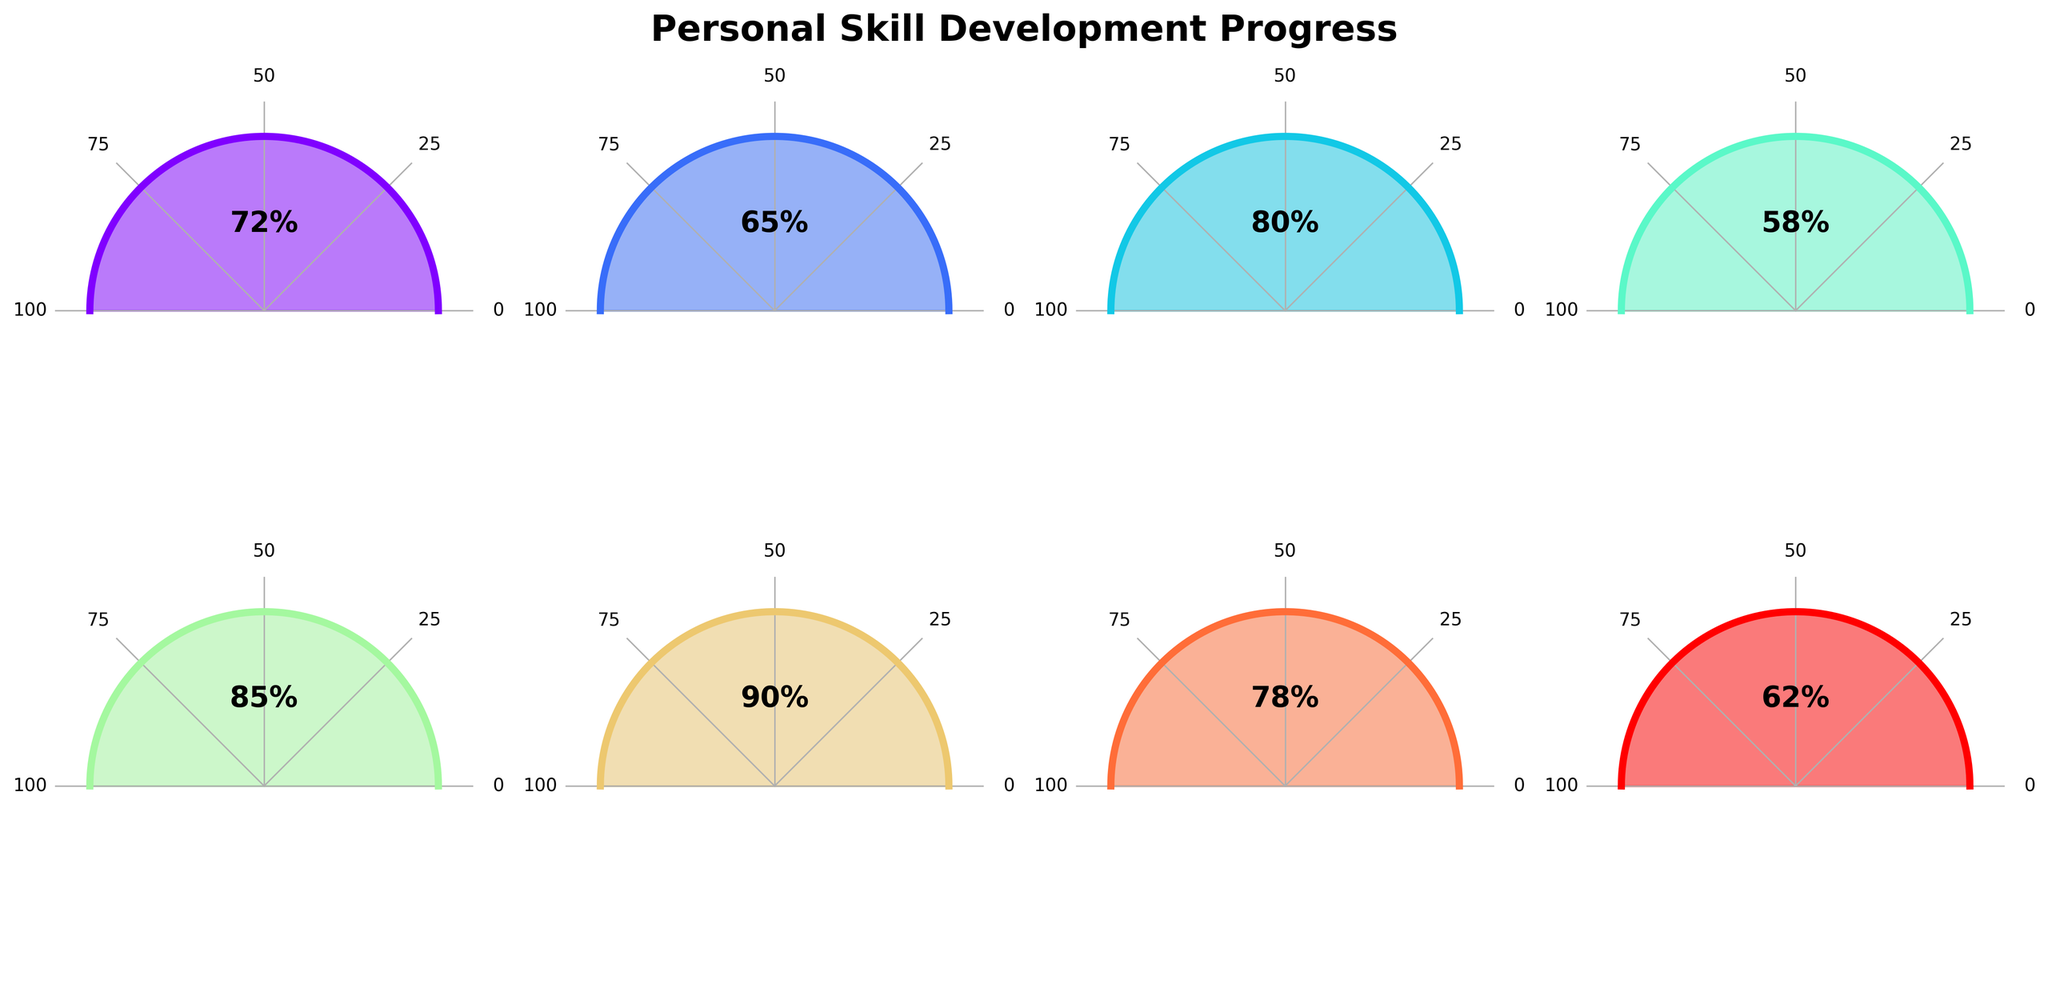What's the title of the figure? The title of the figure is displayed at the top and often serves to provide a brief explanation of what the figure depicts. In this case, the title clearly states, "Personal Skill Development Progress."
Answer: Personal Skill Development Progress How many skills are being tracked in this figure? Each subplot in the figure represents a different skill being tracked. By counting the number of subplots, you can determine how many skills are included. In this figure, there are 2 rows with 4 columns, totaling 8 skills.
Answer: 8 Which skill shows the highest progress percentage? To find the skill with the highest progress percentage, look at the percentage values displayed within each gauge plot. The skill with the highest number is the one with the highest progress. In this case, "Teamwork" has the highest progress at 90%.
Answer: Teamwork What is the mean progress percentage of all skills? To determine the mean progress percentage, sum all the progress percentages and then divide by the number of skills. The percentages are: 72, 65, 80, 58, 85, 90, 78, and 62. Summing these up gives 590. Dividing by the number of skills (8) gives a mean of 73.75%.
Answer: 73.75% Which skills have progress percentages greater than 70%? To find which skills have a progress percentage greater than 70%, scan each subplot for the provided percentage and see which ones are above 70. The skills that satisfy this condition are Communication (72%), Time Management (80%), Problem Solving (85%), Teamwork (90%), and Adaptability (78%).
Answer: Communication, Time Management, Problem Solving, Teamwork, Adaptability Which skill shows the lowest progress percentage? To identify the skill with the lowest progress, look at the percentage in each gauge plot and find the lowest number. Here, "Technical Writing" has the lowest progress at 58%.
Answer: Technical Writing What is the range of progress percentages shown in the figure? The range can be calculated by finding the difference between the highest and lowest progress percentages. The highest percentage is 90% (Teamwork), and the lowest is 58% (Technical Writing). So, the range is 90 - 58 = 32.
Answer: 32 Among Communication, Project Management, and Leadership, which skill has the highest progress? Compare the progress percentages of the skills Communication (72%), Project Management (65%), and Leadership (62%), to determine which has the highest progress. Communication has the highest progress at 72%.
Answer: Communication What proportion of skills have progress percentages below the mean progress percentage? First, find the mean progress (73.75%). Count the number of skills below this mean. Those below 73.75% are Project Management (65%), Technical Writing (58%), Leadership (62%). Out of 8 skills, 3 are below the mean. The proportion is 3/8, which simplifies to 0.375 or 37.5%.
Answer: 37.5% What is the median progress percentage? To find the median, list the progress percentages in ascending order: 58, 62, 65, 72, 78, 80, 85, 90. The median is the middle value. For an even number of data points, it's the average of the two middle numbers. So, the median is (72 + 78) / 2 = 75%.
Answer: 75% 